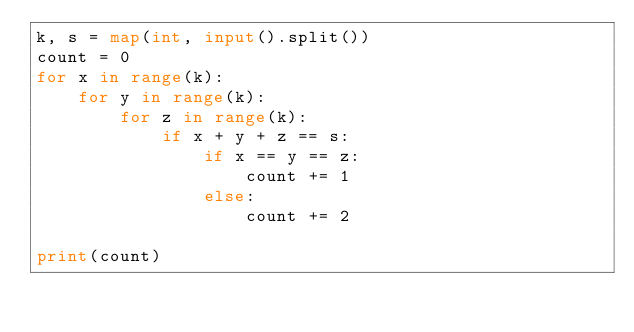<code> <loc_0><loc_0><loc_500><loc_500><_Python_>k, s = map(int, input().split())
count = 0
for x in range(k):
    for y in range(k):
        for z in range(k):
            if x + y + z == s:
                if x == y == z:
                    count += 1
                else:
                    count += 2

print(count)
</code> 